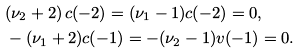<formula> <loc_0><loc_0><loc_500><loc_500>& ( \nu _ { 2 } + 2 ) \, c ( - 2 ) = ( \nu _ { 1 } - 1 ) c ( - 2 ) = 0 , \\ & - ( \nu _ { 1 } + 2 ) c ( - 1 ) = - ( \nu _ { 2 } - 1 ) v ( - 1 ) = 0 .</formula> 